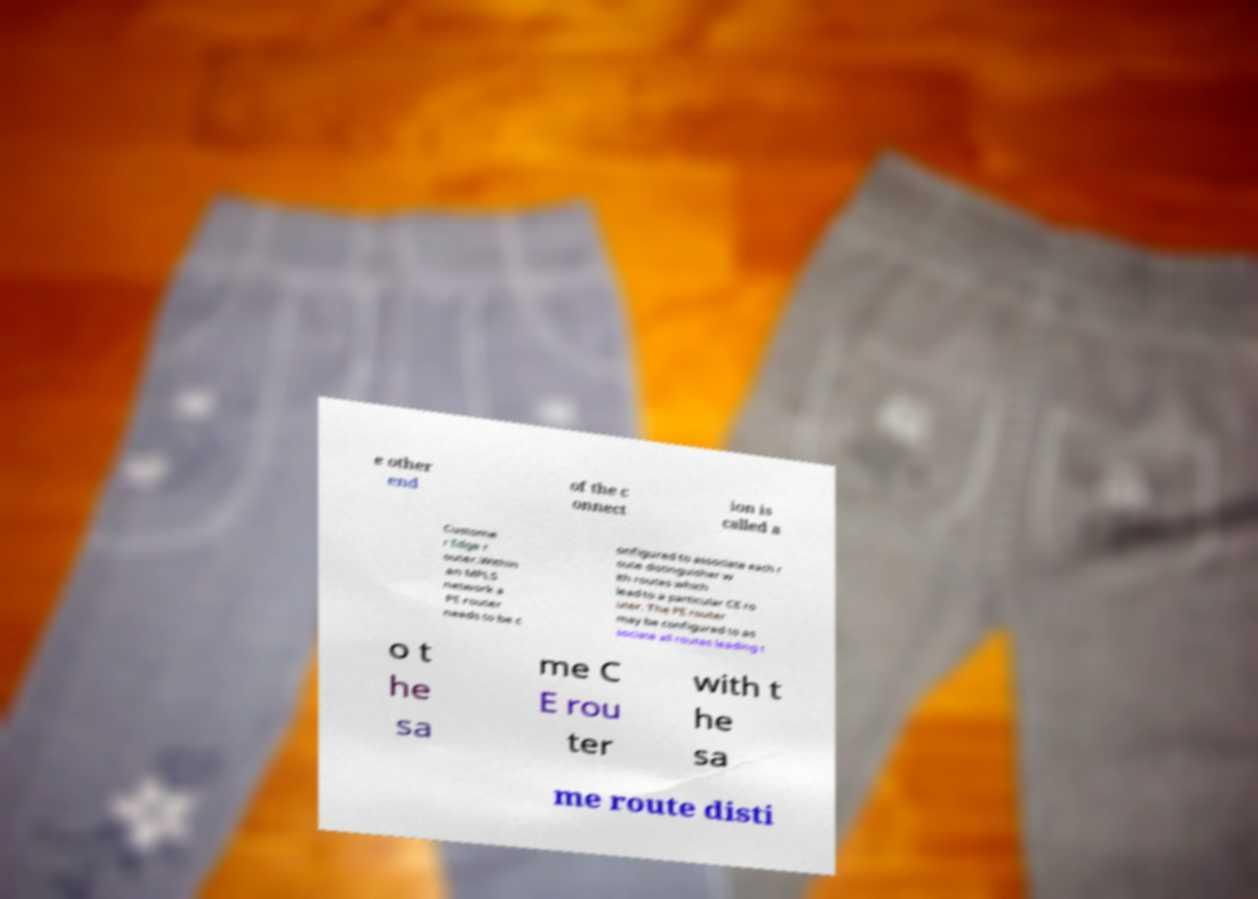Please read and relay the text visible in this image. What does it say? e other end of the c onnect ion is called a Custome r Edge r outer.Within an MPLS network a PE router needs to be c onfigured to associate each r oute distinguisher w ith routes which lead to a particular CE ro uter. The PE router may be configured to as sociate all routes leading t o t he sa me C E rou ter with t he sa me route disti 